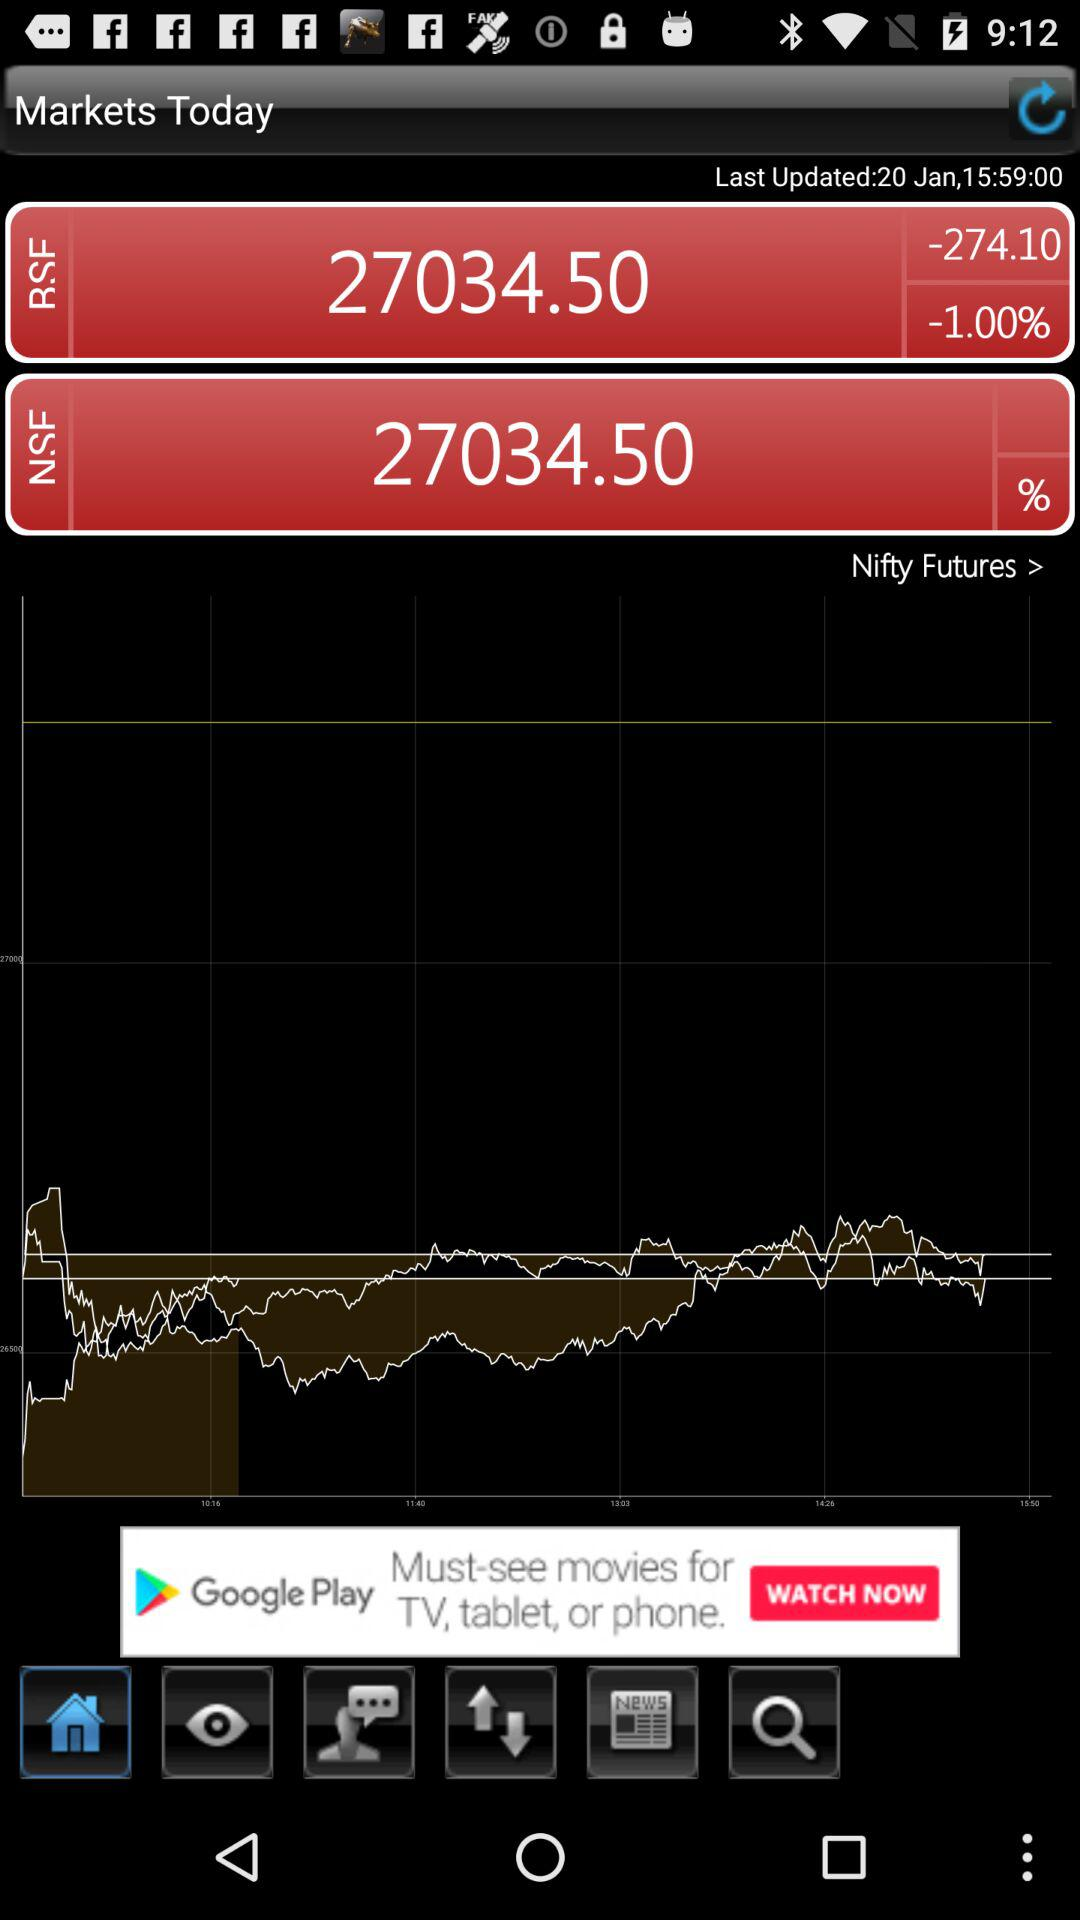What is the price of the stock in BSE? The price of the stock in BSE is 27034.50. 